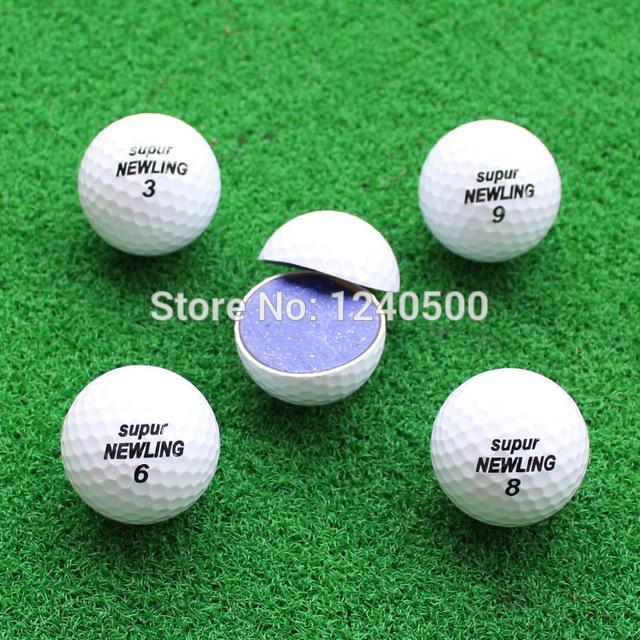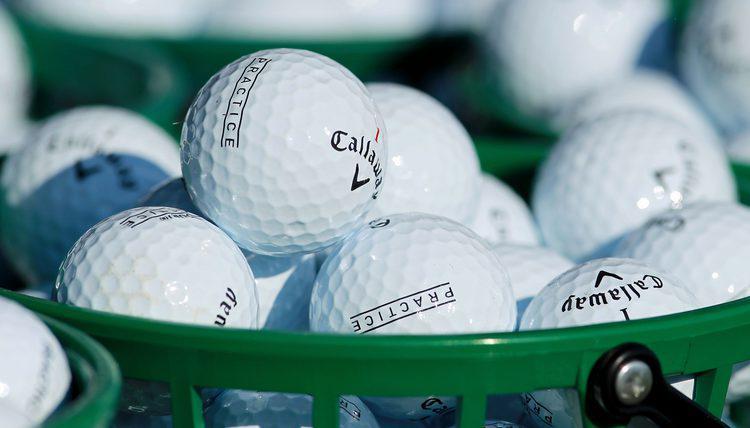The first image is the image on the left, the second image is the image on the right. For the images displayed, is the sentence "An image shows a green container filled with only white golf balls." factually correct? Answer yes or no. Yes. The first image is the image on the left, the second image is the image on the right. Analyze the images presented: Is the assertion "The balls in the image on the right are sitting in a green basket." valid? Answer yes or no. Yes. 